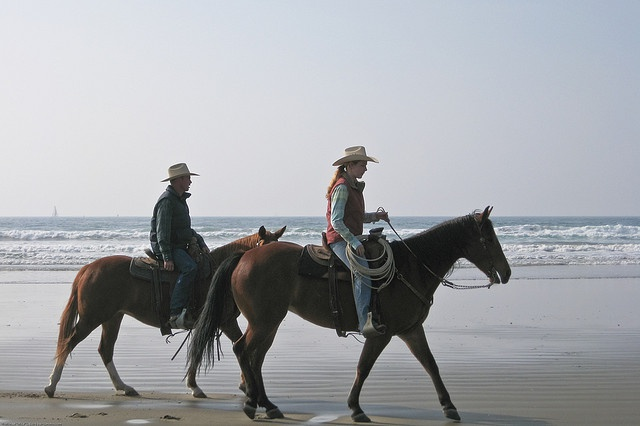Describe the objects in this image and their specific colors. I can see horse in lavender, black, gray, and darkgray tones, horse in lightgray, black, gray, darkgray, and maroon tones, people in lightgray, gray, black, darkgray, and blue tones, people in lightgray, black, gray, and darkgray tones, and boat in lightgray and darkgray tones in this image. 